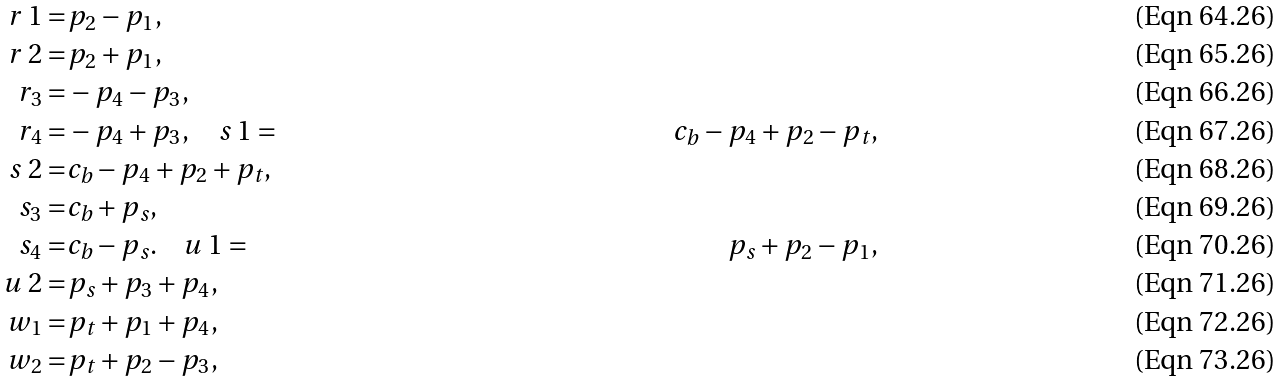<formula> <loc_0><loc_0><loc_500><loc_500>r _ { \ } 1 = & p _ { 2 } - p _ { 1 } , \\ r _ { \ } 2 = & p _ { 2 } + p _ { 1 } , \\ r _ { 3 } = & - p _ { 4 } - p _ { 3 } , \\ r _ { 4 } = & - p _ { 4 } + p _ { 3 } , \quad s _ { \ } 1 = & c _ { b } - p _ { 4 } + p _ { 2 } - p _ { t } , \\ s _ { \ } 2 = & c _ { b } - p _ { 4 } + p _ { 2 } + p _ { t } , \\ s _ { 3 } = & c _ { b } + p _ { s } , \\ s _ { 4 } = & c _ { b } - p _ { s } . \quad u _ { \ } 1 = & p _ { s } + p _ { 2 } - p _ { 1 } , \\ u _ { \ } 2 = & p _ { s } + p _ { 3 } + p _ { 4 } , \\ w _ { 1 } = & p _ { t } + p _ { 1 } + p _ { 4 } , \\ w _ { 2 } = & p _ { t } + p _ { 2 } - p _ { 3 } ,</formula> 